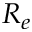<formula> <loc_0><loc_0><loc_500><loc_500>R _ { e }</formula> 